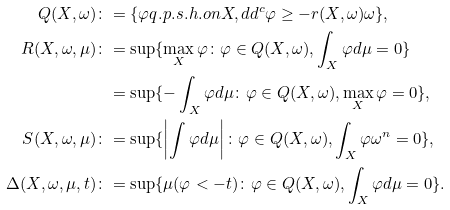<formula> <loc_0><loc_0><loc_500><loc_500>Q ( X , \omega ) \colon & = \{ \varphi q . p . s . h . o n X , d d ^ { c } \varphi \geq - r ( X , \omega ) \omega \} , \\ R ( X , \omega , \mu ) \colon & = \sup \{ \max _ { X } \varphi \colon \varphi \in Q ( X , \omega ) , \int _ { X } \varphi d \mu = 0 \} \\ & = \sup \{ - \int _ { X } \varphi d \mu \colon \varphi \in Q ( X , \omega ) , \max _ { X } \varphi = 0 \} , \\ S ( X , \omega , \mu ) \colon & = \sup \{ \left | \int \varphi d \mu \right | \colon \varphi \in Q ( X , \omega ) , \int _ { X } \varphi \omega ^ { n } = 0 \} , \\ \Delta ( X , \omega , \mu , t ) \colon & = \sup \{ \mu ( \varphi < - t ) \colon \varphi \in Q ( X , \omega ) , \int _ { X } \varphi d \mu = 0 \} . \\</formula> 